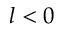<formula> <loc_0><loc_0><loc_500><loc_500>l < 0</formula> 